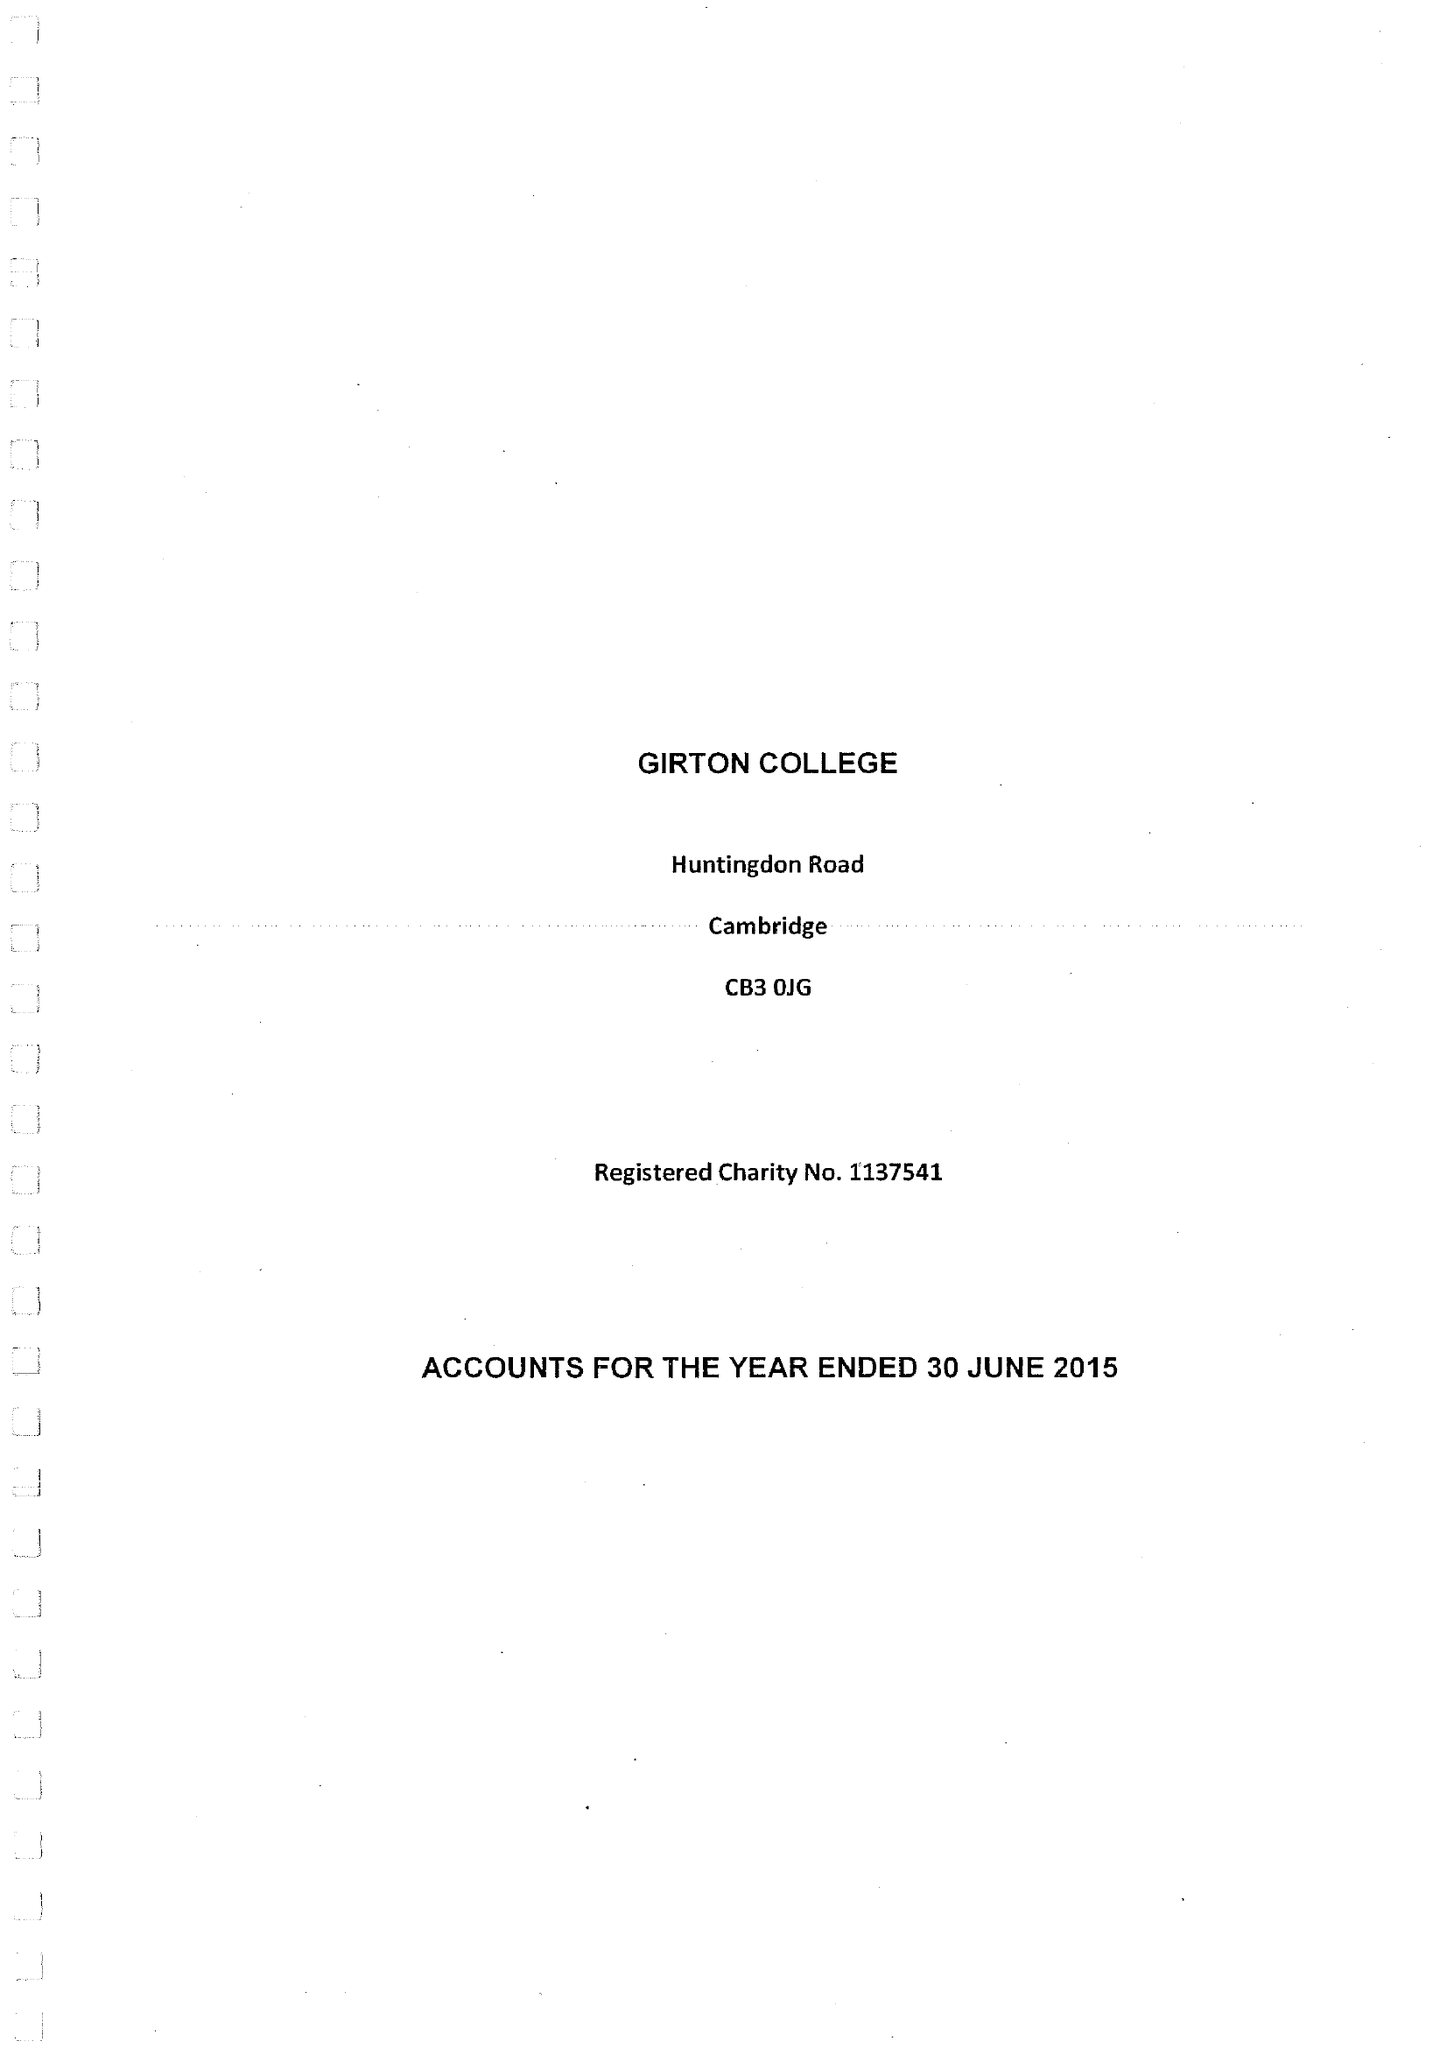What is the value for the address__post_town?
Answer the question using a single word or phrase. CAMBRIDGE 